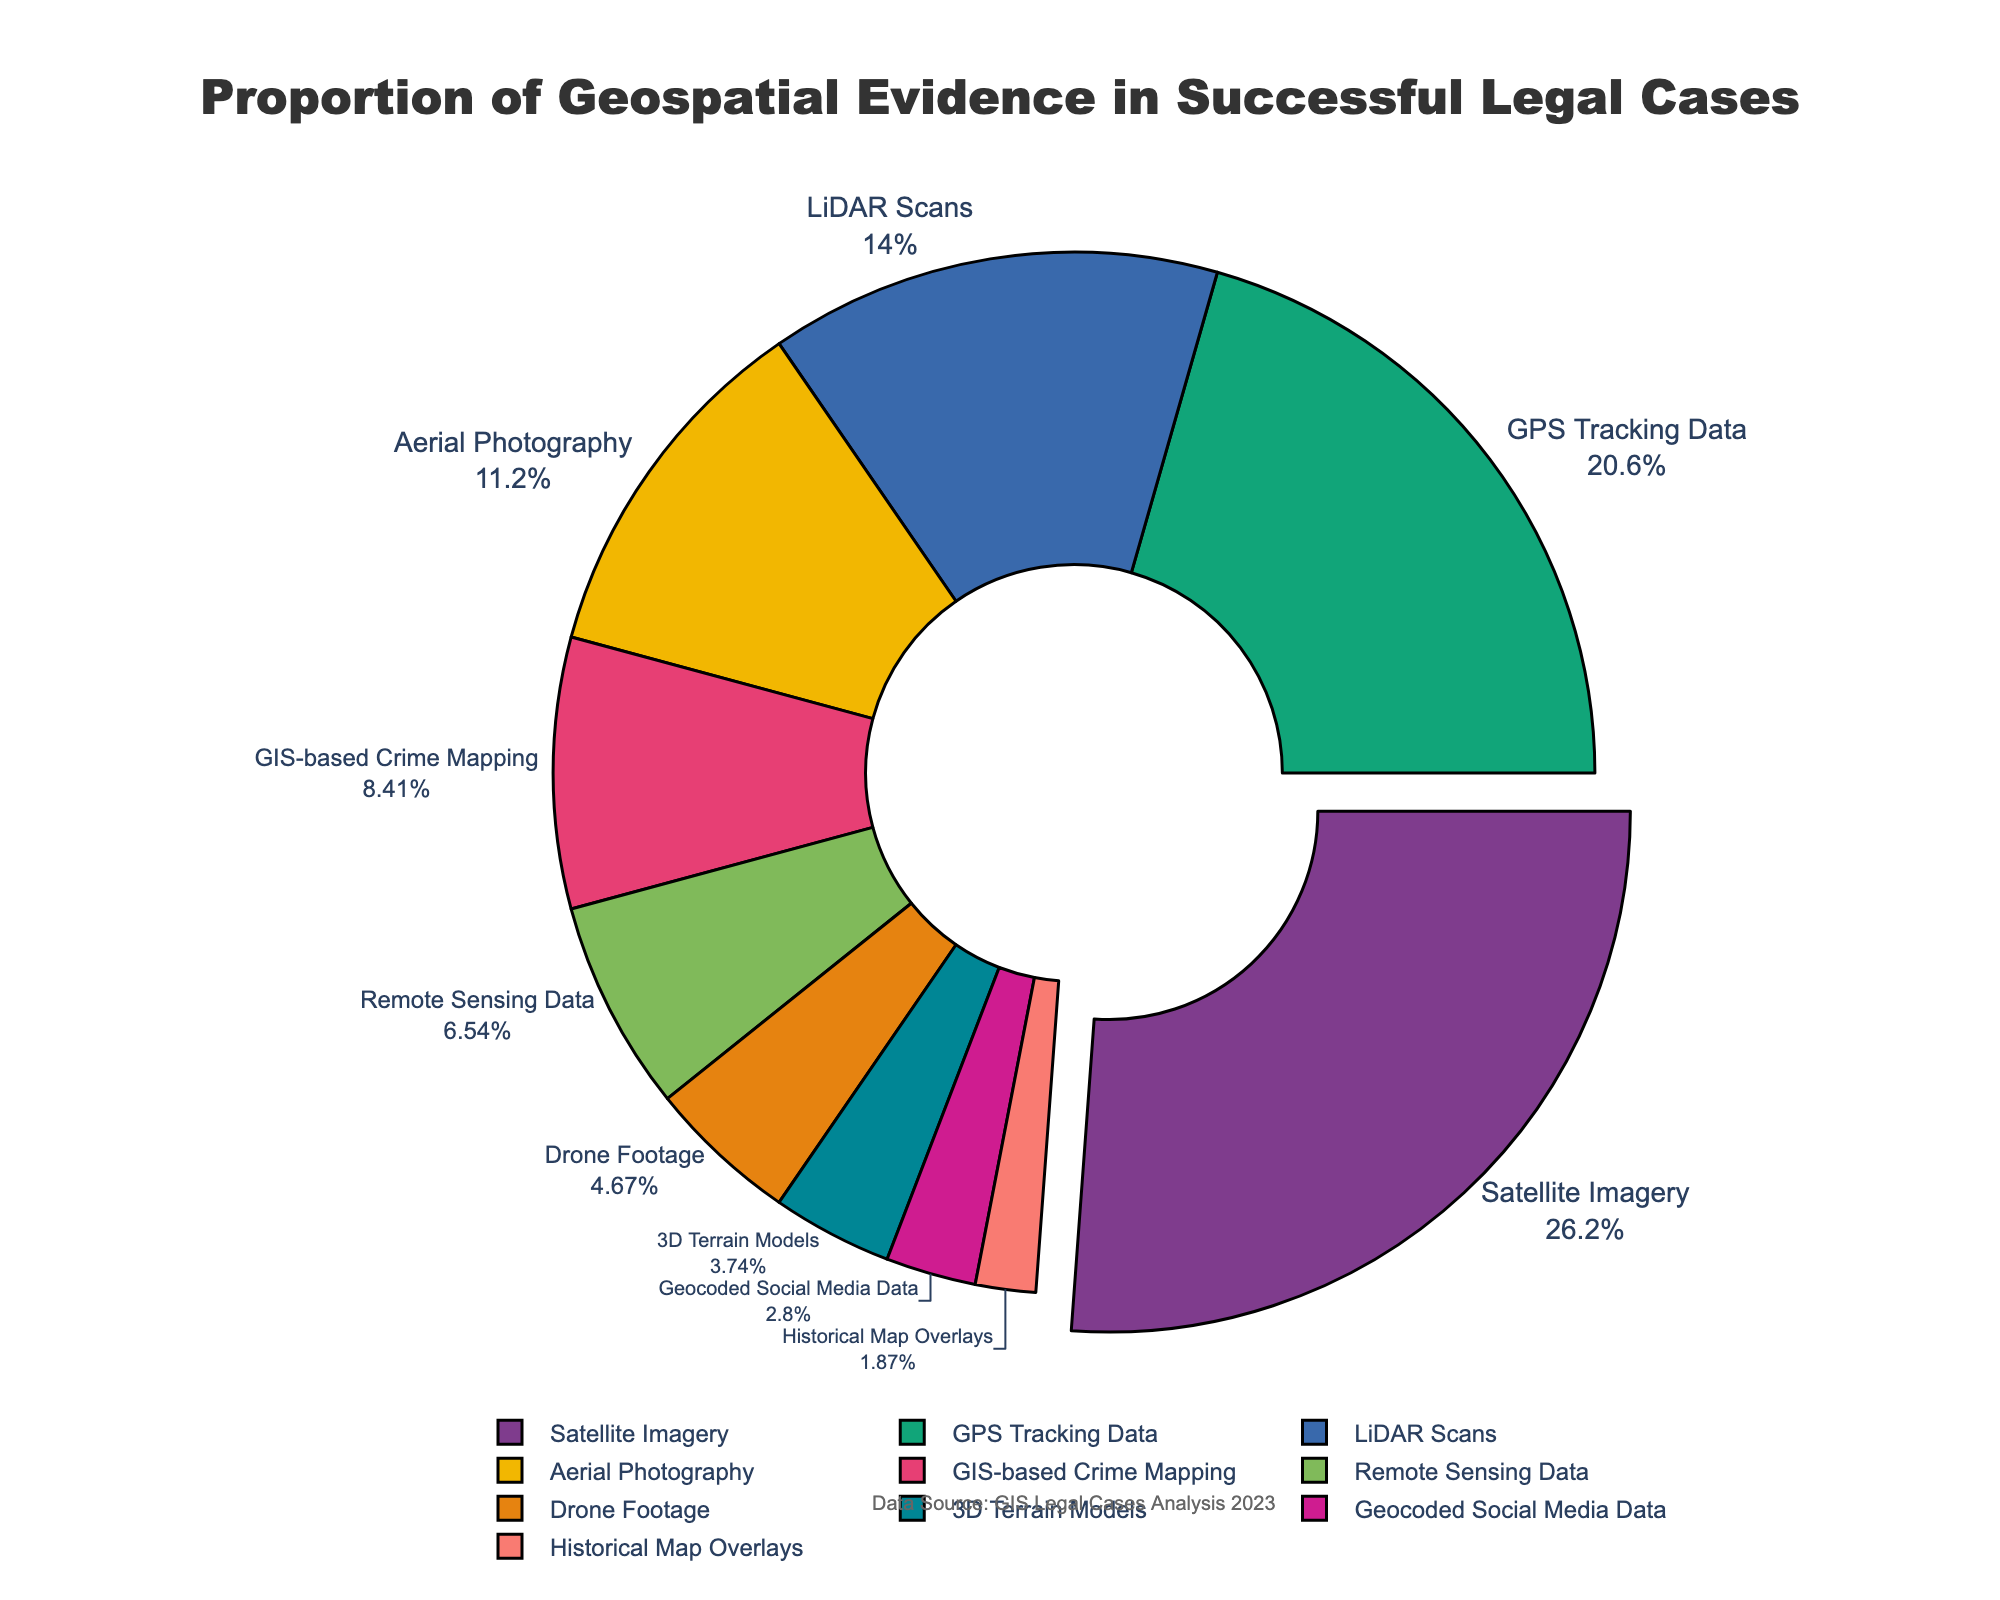Which type of geospatial evidence has the highest proportion? Look for the largest segment in the pie chart. The largest segment should have a higher percentage compared to others. The slice pulled out slightly should help identify this.
Answer: Satellite Imagery What is the combined proportion of GPS Tracking Data and LiDAR Scans? Add the percentages of GPS Tracking Data (22%) and LiDAR Scans (15%). 22% + 15% equals 37%.
Answer: 37% Which evidence type has a lower proportion, Aerial Photography or GIS-based Crime Mapping? Compare the percentages of Aerial Photography (12%) and GIS-based Crime Mapping (9%). 9% is lower than 12%.
Answer: GIS-based Crime Mapping What is the total proportion of all types of geospatial evidence that have less than 10% each? Sum the percentages of GIS-based Crime Mapping (9%), Remote Sensing Data (7%), Drone Footage (5%), 3D Terrain Models (4%), Geocoded Social Media Data (3%), and Historical Map Overlays (2%). The total is 9% + 7% + 5% + 4% + 3% + 2% = 30%.
Answer: 30% Which geospatial evidence type has the smallest proportion? Identify the smallest segment in the pie chart. The smallest segment indicates the lowest percentage. The lowest percentage given is 2%.
Answer: Historical Map Overlays Are there more types of evidence that have a proportion greater than or equal to 10% or less than 10%? Count the number of evidence types with proportions greater than or equal to 10% (Satellite Imagery, GPS Tracking Data, LiDAR Scans, Aerial Photography) and those less than 10% (GIS-based Crime Mapping, Remote Sensing Data, Drone Footage, 3D Terrain Models, Geocoded Social Media Data, Historical Map Overlays). There are 4 types greater than or equal to 10% and 6 less than 10%.
Answer: Less than 10% What is the percentage difference between Satellite Imagery and Drone Footage? Subtract the percentage of Drone Footage (5%) from that of Satellite Imagery (28%). 28% - 5% = 23%.
Answer: 23% Which evidence type uses a lighter color in the pie chart, LiDAR Scans or Drone Footage? Observe the colors in the chart. Since LiDAR Scans likely use one of the bold colors and Drone Footage one of the pastel colors, Drone Footage will appear lighter.
Answer: Drone Footage What's the proportion difference between the highest and the lowest types of evidence? Subtract the lowest percentage (2% for Historical Map Overlays) from the highest percentage (28% for Satellite Imagery). 28% - 2% = 26%.
Answer: 26% 